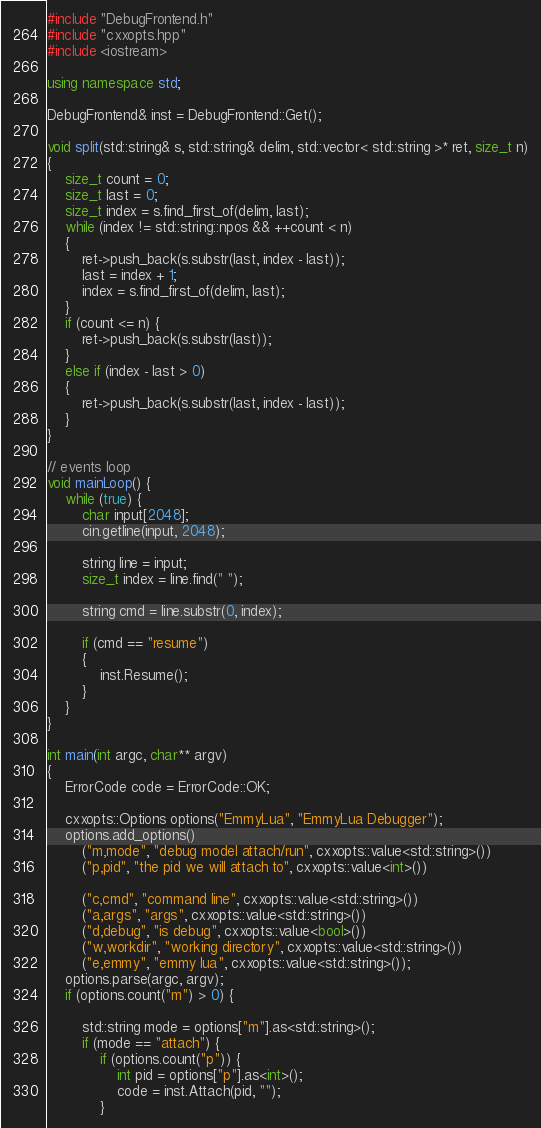<code> <loc_0><loc_0><loc_500><loc_500><_C++_>#include "DebugFrontend.h"
#include "cxxopts.hpp"
#include <iostream>

using namespace std;

DebugFrontend& inst = DebugFrontend::Get();

void split(std::string& s, std::string& delim, std::vector< std::string >* ret, size_t n)
{
	size_t count = 0;
	size_t last = 0;
	size_t index = s.find_first_of(delim, last);
	while (index != std::string::npos && ++count < n)
	{
		ret->push_back(s.substr(last, index - last));
		last = index + 1;
		index = s.find_first_of(delim, last);
	}
	if (count <= n) {
		ret->push_back(s.substr(last));
	}
	else if (index - last > 0)
	{
		ret->push_back(s.substr(last, index - last));
	}
}

// events loop
void mainLoop() {
	while (true) {
		char input[2048];
		cin.getline(input, 2048);

		string line = input;
		size_t index = line.find(" ");

		string cmd = line.substr(0, index);

		if (cmd == "resume")
		{
			inst.Resume();
		}
	}
}

int main(int argc, char** argv)
{
	ErrorCode code = ErrorCode::OK;

	cxxopts::Options options("EmmyLua", "EmmyLua Debugger");
	options.add_options()
		("m,mode", "debug model attach/run", cxxopts::value<std::string>())
		("p,pid", "the pid we will attach to", cxxopts::value<int>())

		("c,cmd", "command line", cxxopts::value<std::string>())
		("a,args", "args", cxxopts::value<std::string>())
		("d,debug", "is debug", cxxopts::value<bool>())
		("w,workdir", "working directory", cxxopts::value<std::string>())
		("e,emmy", "emmy lua", cxxopts::value<std::string>());
	options.parse(argc, argv);
	if (options.count("m") > 0) {

		std::string mode = options["m"].as<std::string>();
		if (mode == "attach") {
			if (options.count("p")) {
				int pid = options["p"].as<int>();
				code = inst.Attach(pid, "");
			}</code> 